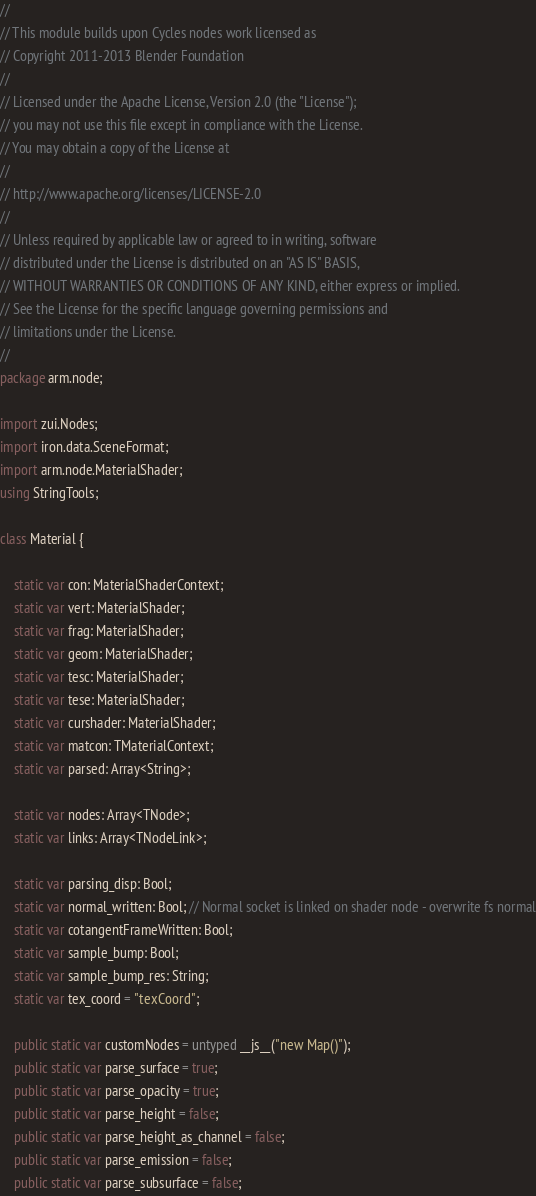Convert code to text. <code><loc_0><loc_0><loc_500><loc_500><_Haxe_>//
// This module builds upon Cycles nodes work licensed as
// Copyright 2011-2013 Blender Foundation
//
// Licensed under the Apache License, Version 2.0 (the "License");
// you may not use this file except in compliance with the License.
// You may obtain a copy of the License at
//
// http://www.apache.org/licenses/LICENSE-2.0
//
// Unless required by applicable law or agreed to in writing, software
// distributed under the License is distributed on an "AS IS" BASIS,
// WITHOUT WARRANTIES OR CONDITIONS OF ANY KIND, either express or implied.
// See the License for the specific language governing permissions and
// limitations under the License.
//
package arm.node;

import zui.Nodes;
import iron.data.SceneFormat;
import arm.node.MaterialShader;
using StringTools;

class Material {

	static var con: MaterialShaderContext;
	static var vert: MaterialShader;
	static var frag: MaterialShader;
	static var geom: MaterialShader;
	static var tesc: MaterialShader;
	static var tese: MaterialShader;
	static var curshader: MaterialShader;
	static var matcon: TMaterialContext;
	static var parsed: Array<String>;

	static var nodes: Array<TNode>;
	static var links: Array<TNodeLink>;

	static var parsing_disp: Bool;
	static var normal_written: Bool; // Normal socket is linked on shader node - overwrite fs normal
	static var cotangentFrameWritten: Bool;
	static var sample_bump: Bool;
	static var sample_bump_res: String;
	static var tex_coord = "texCoord";

	public static var customNodes = untyped __js__("new Map()");
	public static var parse_surface = true;
	public static var parse_opacity = true;
	public static var parse_height = false;
	public static var parse_height_as_channel = false;
	public static var parse_emission = false;
	public static var parse_subsurface = false;</code> 